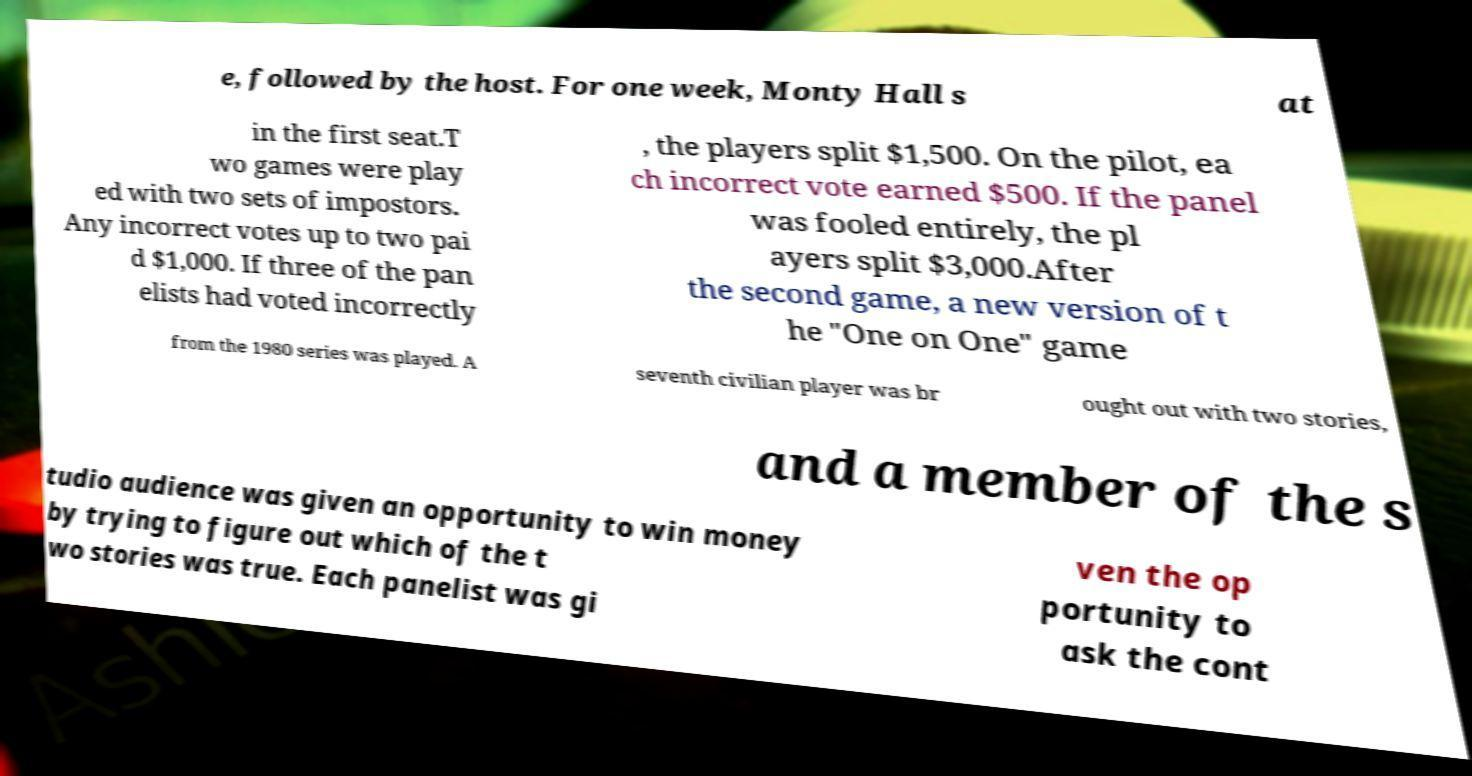Could you assist in decoding the text presented in this image and type it out clearly? e, followed by the host. For one week, Monty Hall s at in the first seat.T wo games were play ed with two sets of impostors. Any incorrect votes up to two pai d $1,000. If three of the pan elists had voted incorrectly , the players split $1,500. On the pilot, ea ch incorrect vote earned $500. If the panel was fooled entirely, the pl ayers split $3,000.After the second game, a new version of t he "One on One" game from the 1980 series was played. A seventh civilian player was br ought out with two stories, and a member of the s tudio audience was given an opportunity to win money by trying to figure out which of the t wo stories was true. Each panelist was gi ven the op portunity to ask the cont 